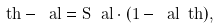Convert formula to latex. <formula><loc_0><loc_0><loc_500><loc_500>\ t h - \ a l = S _ { \ } a l \cdot ( 1 - \bar { \ } a l \ t h ) ,</formula> 